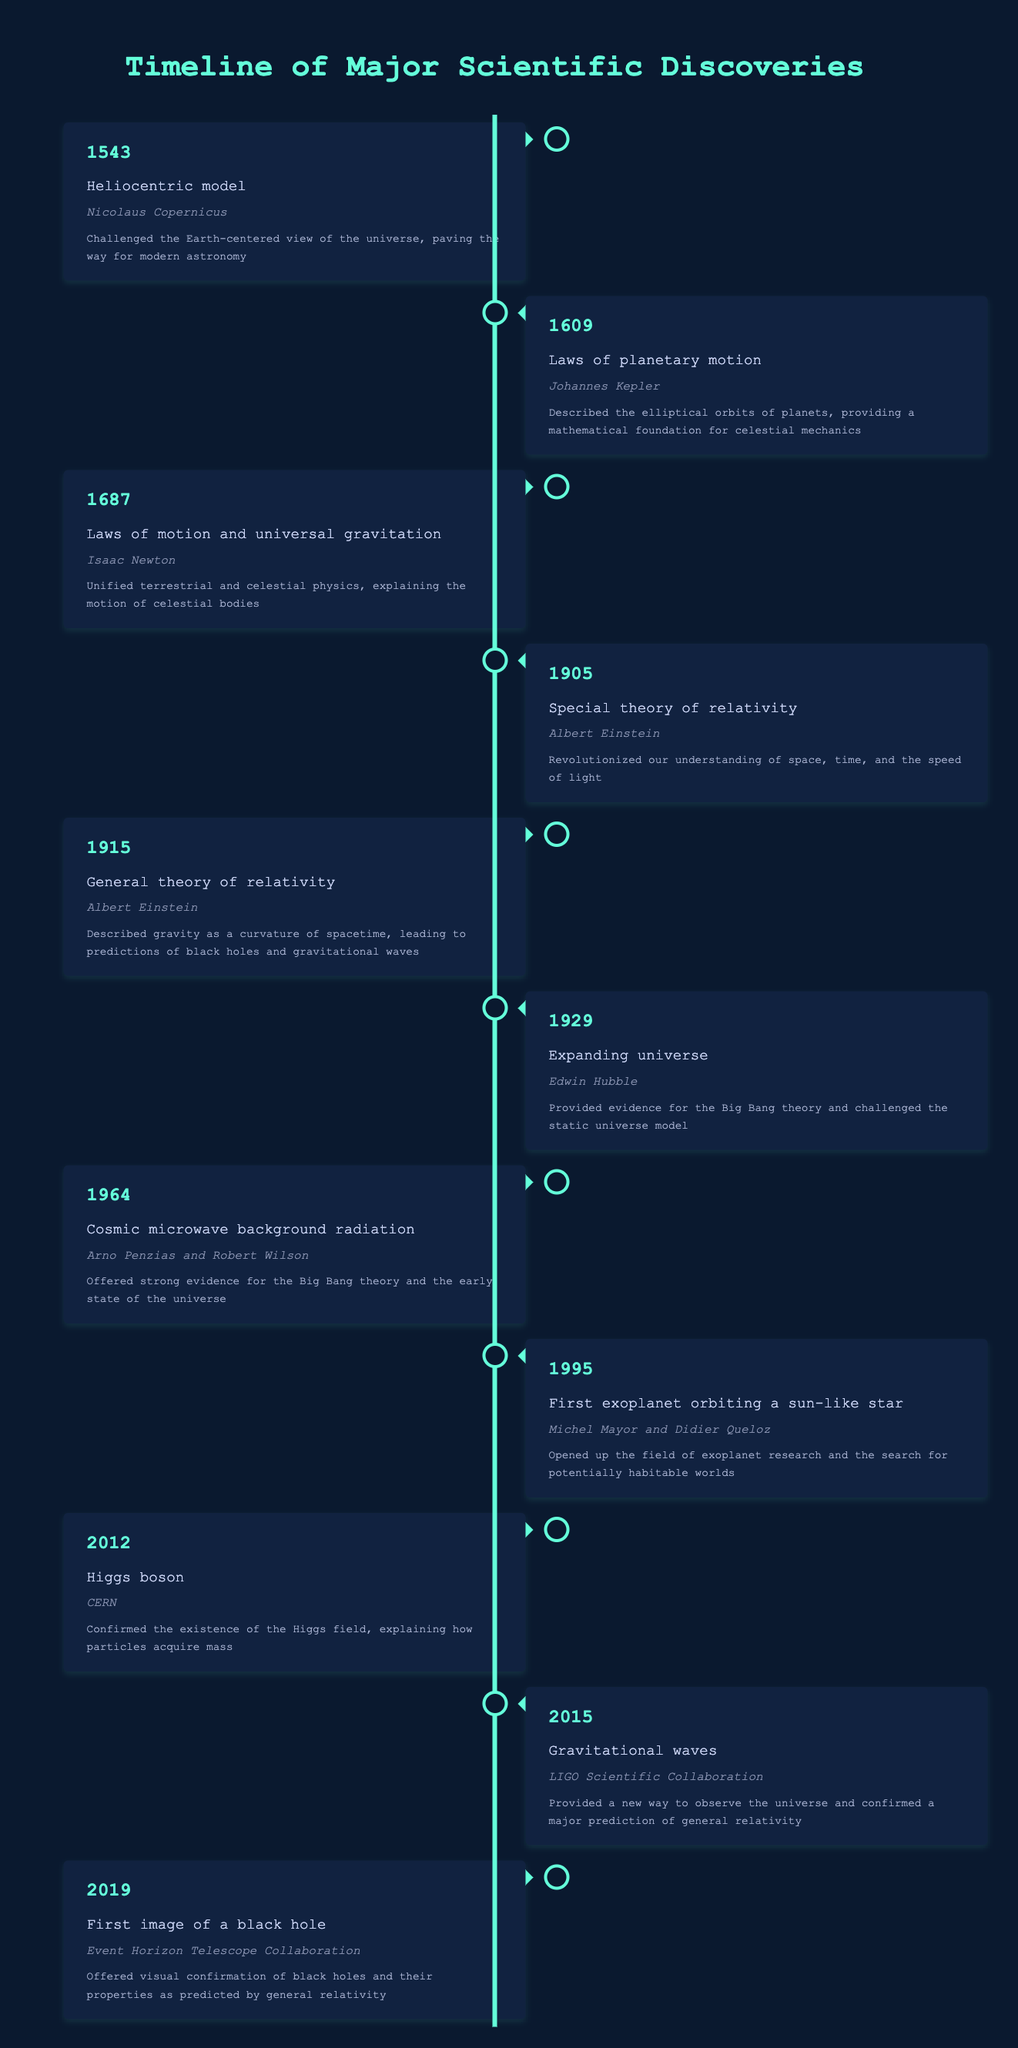What year was the heliocentric model discovered? The heliocentric model was discovered in 1543, as noted in the table under the relevant entry.
Answer: 1543 Who proposed the laws of planetary motion? The laws of planetary motion were proposed by Johannes Kepler, as indicated in the table.
Answer: Johannes Kepler How many years passed between the discovery of the special theory of relativity and the general theory of relativity? The special theory of relativity was discovered in 1905 and the general theory of relativity in 1915. The difference is 1915 - 1905 = 10 years.
Answer: 10 years Did Arno Penzias and Robert Wilson contribute to our understanding of cosmic microwave background radiation? Yes, they are credited with this discovery, as seen in the table's entry for 1964.
Answer: Yes Which discovery came closest to the year 2000? The discovery of the first exoplanet orbiting a sun-like star in 1995 is the closest to 2000, compared to other discoveries, according to the table.
Answer: First exoplanet orbiting a sun-like star What is the total number of discoveries listed in the table? There are 11 entries in the table detailing major scientific discoveries, each corresponding to a significant year and scientist or institution.
Answer: 11 What discovery was made in 2012? The Higgs boson was discovered in 2012, as recorded in the table.
Answer: Higgs boson Which scientist's discoveries include both the special and general theories of relativity? Albert Einstein made both the special theory of relativity in 1905 and the general theory of relativity in 1915, as indicated in two entries in the table.
Answer: Albert Einstein What was the impact of Edwin Hubble’s discovery in 1929? Hubble's discovery in 1929 provided evidence for the Big Bang theory and challenged the concept of a static universe, as seen in the impact statement in the table.
Answer: Provided evidence for the Big Bang theory and challenged the static universe model 